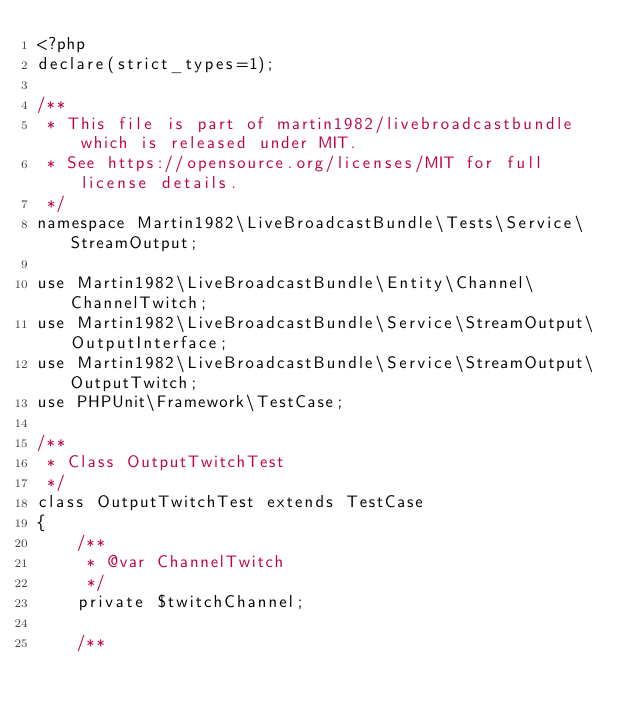<code> <loc_0><loc_0><loc_500><loc_500><_PHP_><?php
declare(strict_types=1);

/**
 * This file is part of martin1982/livebroadcastbundle which is released under MIT.
 * See https://opensource.org/licenses/MIT for full license details.
 */
namespace Martin1982\LiveBroadcastBundle\Tests\Service\StreamOutput;

use Martin1982\LiveBroadcastBundle\Entity\Channel\ChannelTwitch;
use Martin1982\LiveBroadcastBundle\Service\StreamOutput\OutputInterface;
use Martin1982\LiveBroadcastBundle\Service\StreamOutput\OutputTwitch;
use PHPUnit\Framework\TestCase;

/**
 * Class OutputTwitchTest
 */
class OutputTwitchTest extends TestCase
{
    /**
     * @var ChannelTwitch
     */
    private $twitchChannel;

    /**</code> 